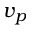<formula> <loc_0><loc_0><loc_500><loc_500>v _ { p }</formula> 